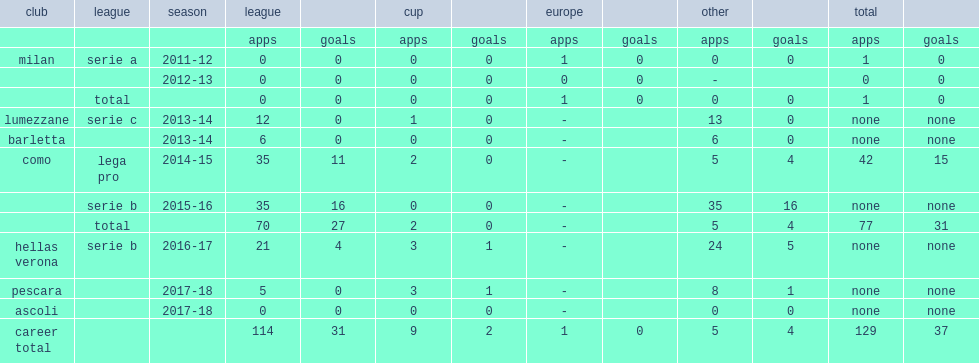Which club did ganz join in the 2014-15 season? Como. 